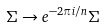<formula> <loc_0><loc_0><loc_500><loc_500>\Sigma \rightarrow e ^ { - 2 \pi i / n } \Sigma</formula> 